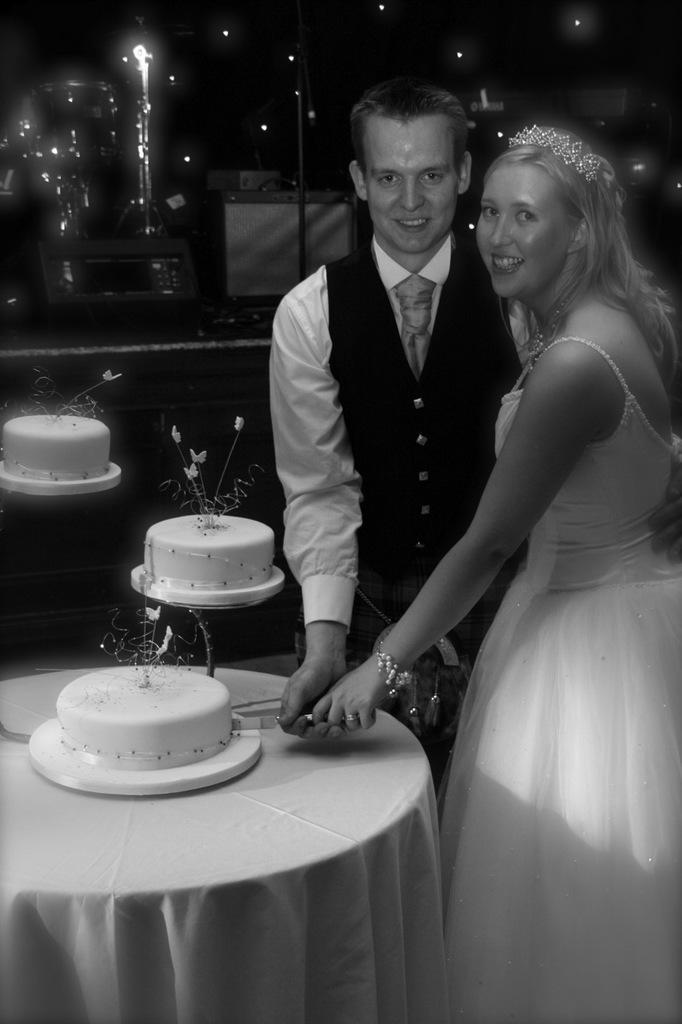Can you describe this image briefly? In this image on the right side there is one man and one woman standing, and they are cutting the cake. In front of them there is a table and cakes, and in the background there is a box and some lights. 